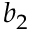<formula> <loc_0><loc_0><loc_500><loc_500>b _ { 2 }</formula> 